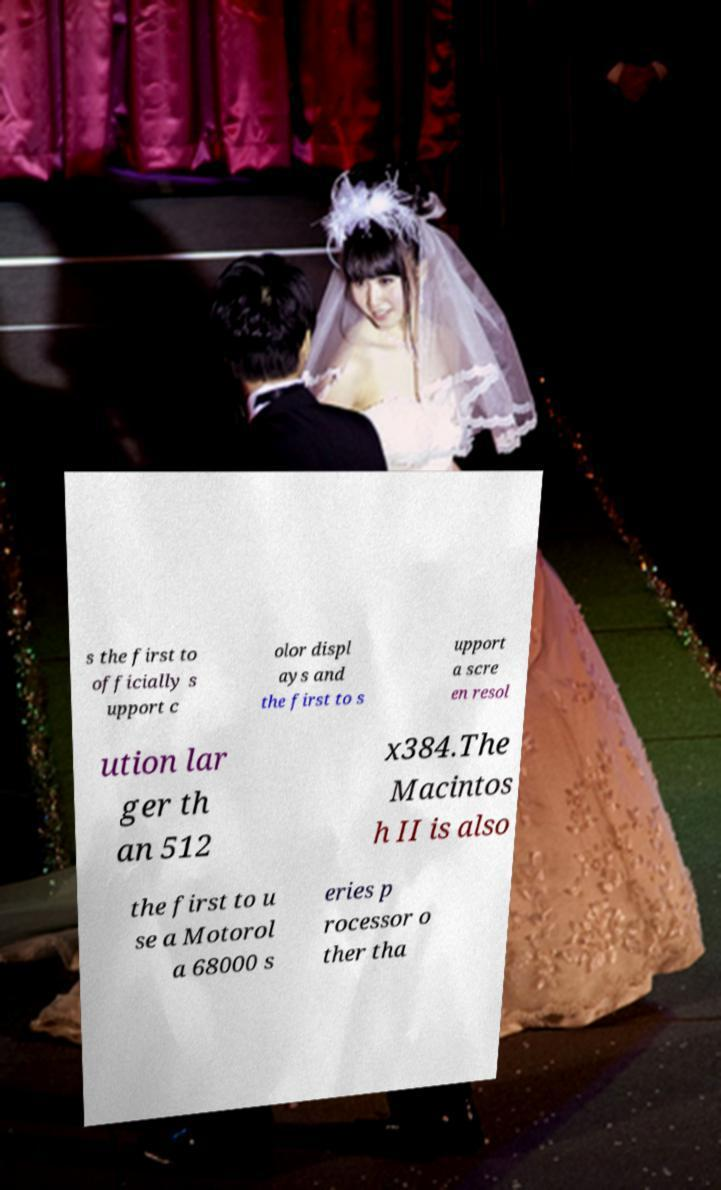For documentation purposes, I need the text within this image transcribed. Could you provide that? s the first to officially s upport c olor displ ays and the first to s upport a scre en resol ution lar ger th an 512 x384.The Macintos h II is also the first to u se a Motorol a 68000 s eries p rocessor o ther tha 